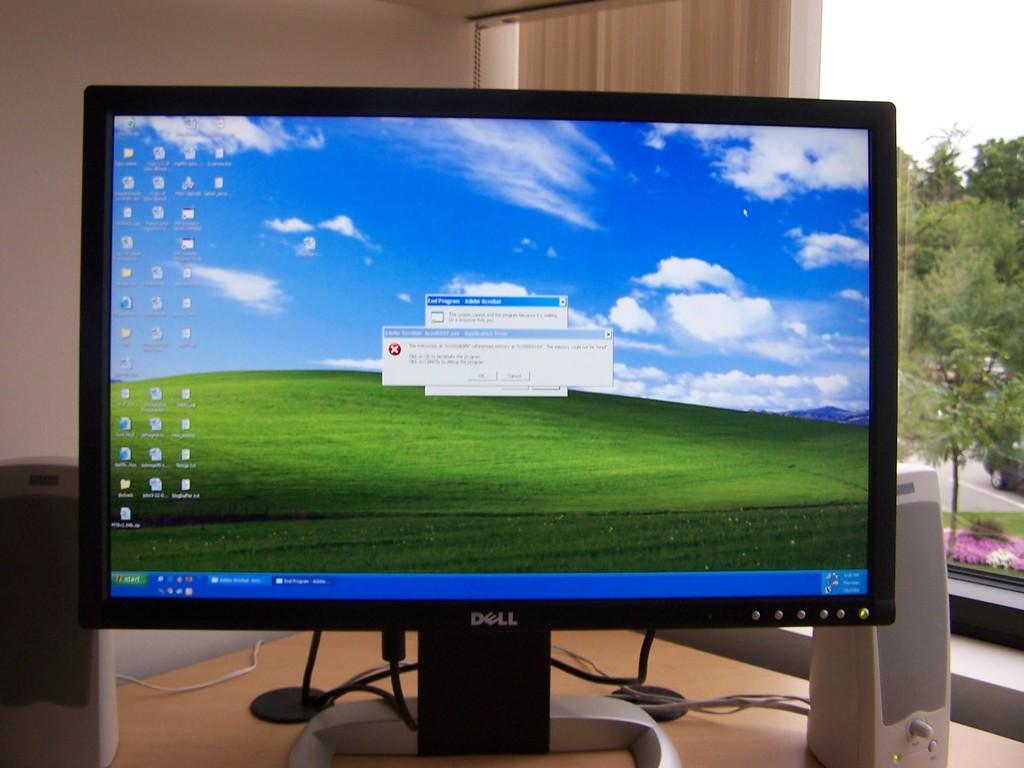Who makes that monitor?
Make the answer very short. Dell. 